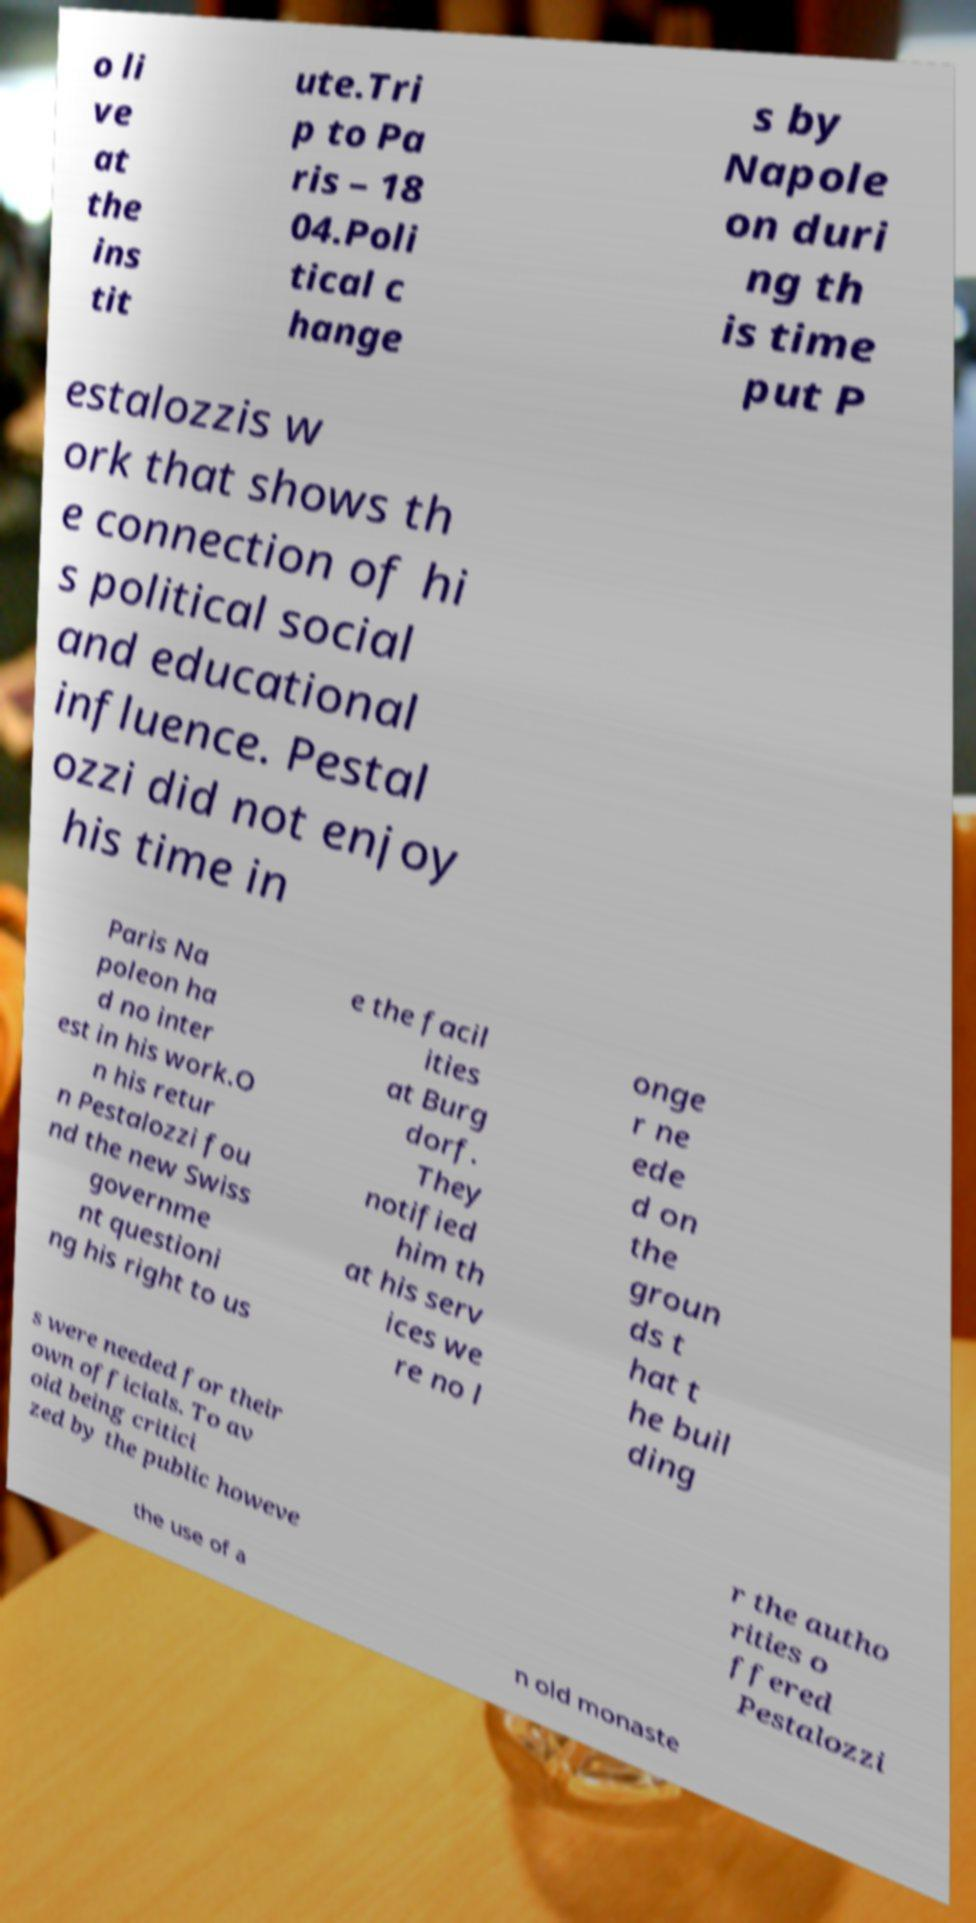Can you accurately transcribe the text from the provided image for me? o li ve at the ins tit ute.Tri p to Pa ris – 18 04.Poli tical c hange s by Napole on duri ng th is time put P estalozzis w ork that shows th e connection of hi s political social and educational influence. Pestal ozzi did not enjoy his time in Paris Na poleon ha d no inter est in his work.O n his retur n Pestalozzi fou nd the new Swiss governme nt questioni ng his right to us e the facil ities at Burg dorf. They notified him th at his serv ices we re no l onge r ne ede d on the groun ds t hat t he buil ding s were needed for their own officials. To av oid being critici zed by the public howeve r the autho rities o ffered Pestalozzi the use of a n old monaste 